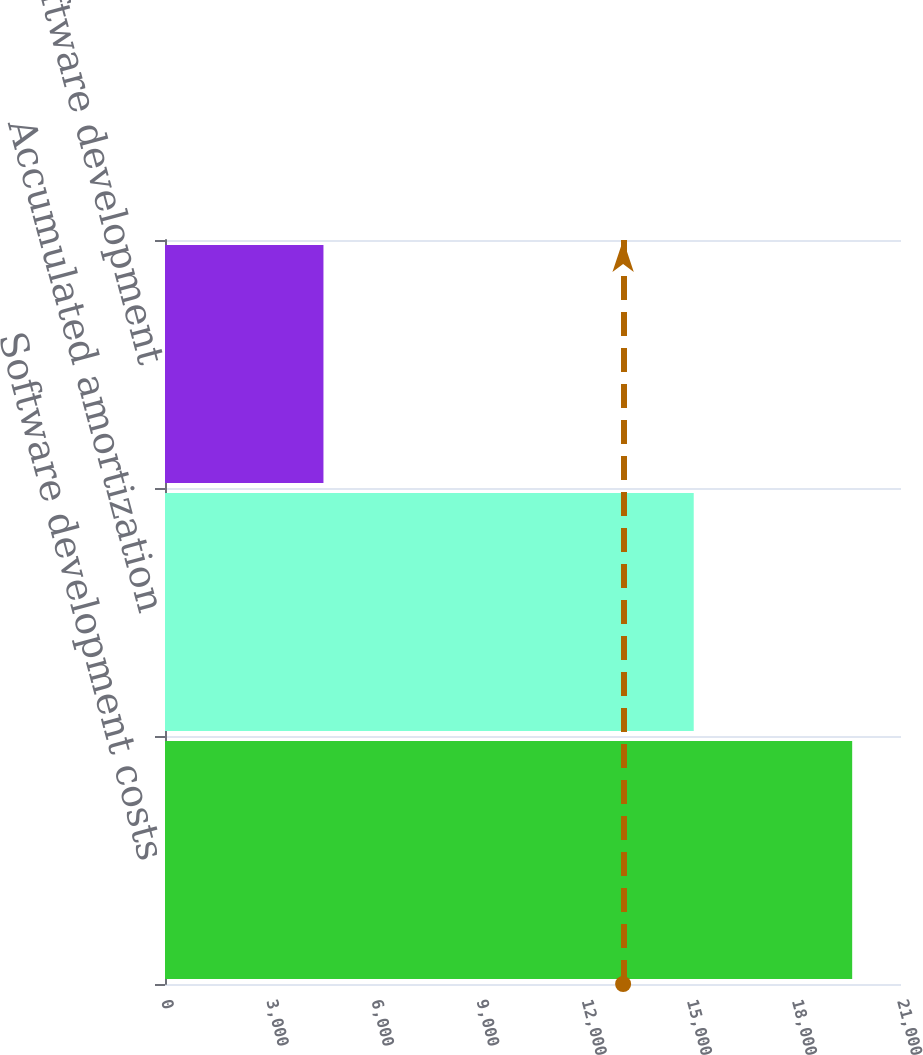<chart> <loc_0><loc_0><loc_500><loc_500><bar_chart><fcel>Software development costs<fcel>Accumulated amortization<fcel>Total software development<nl><fcel>19607<fcel>15086<fcel>4521<nl></chart> 